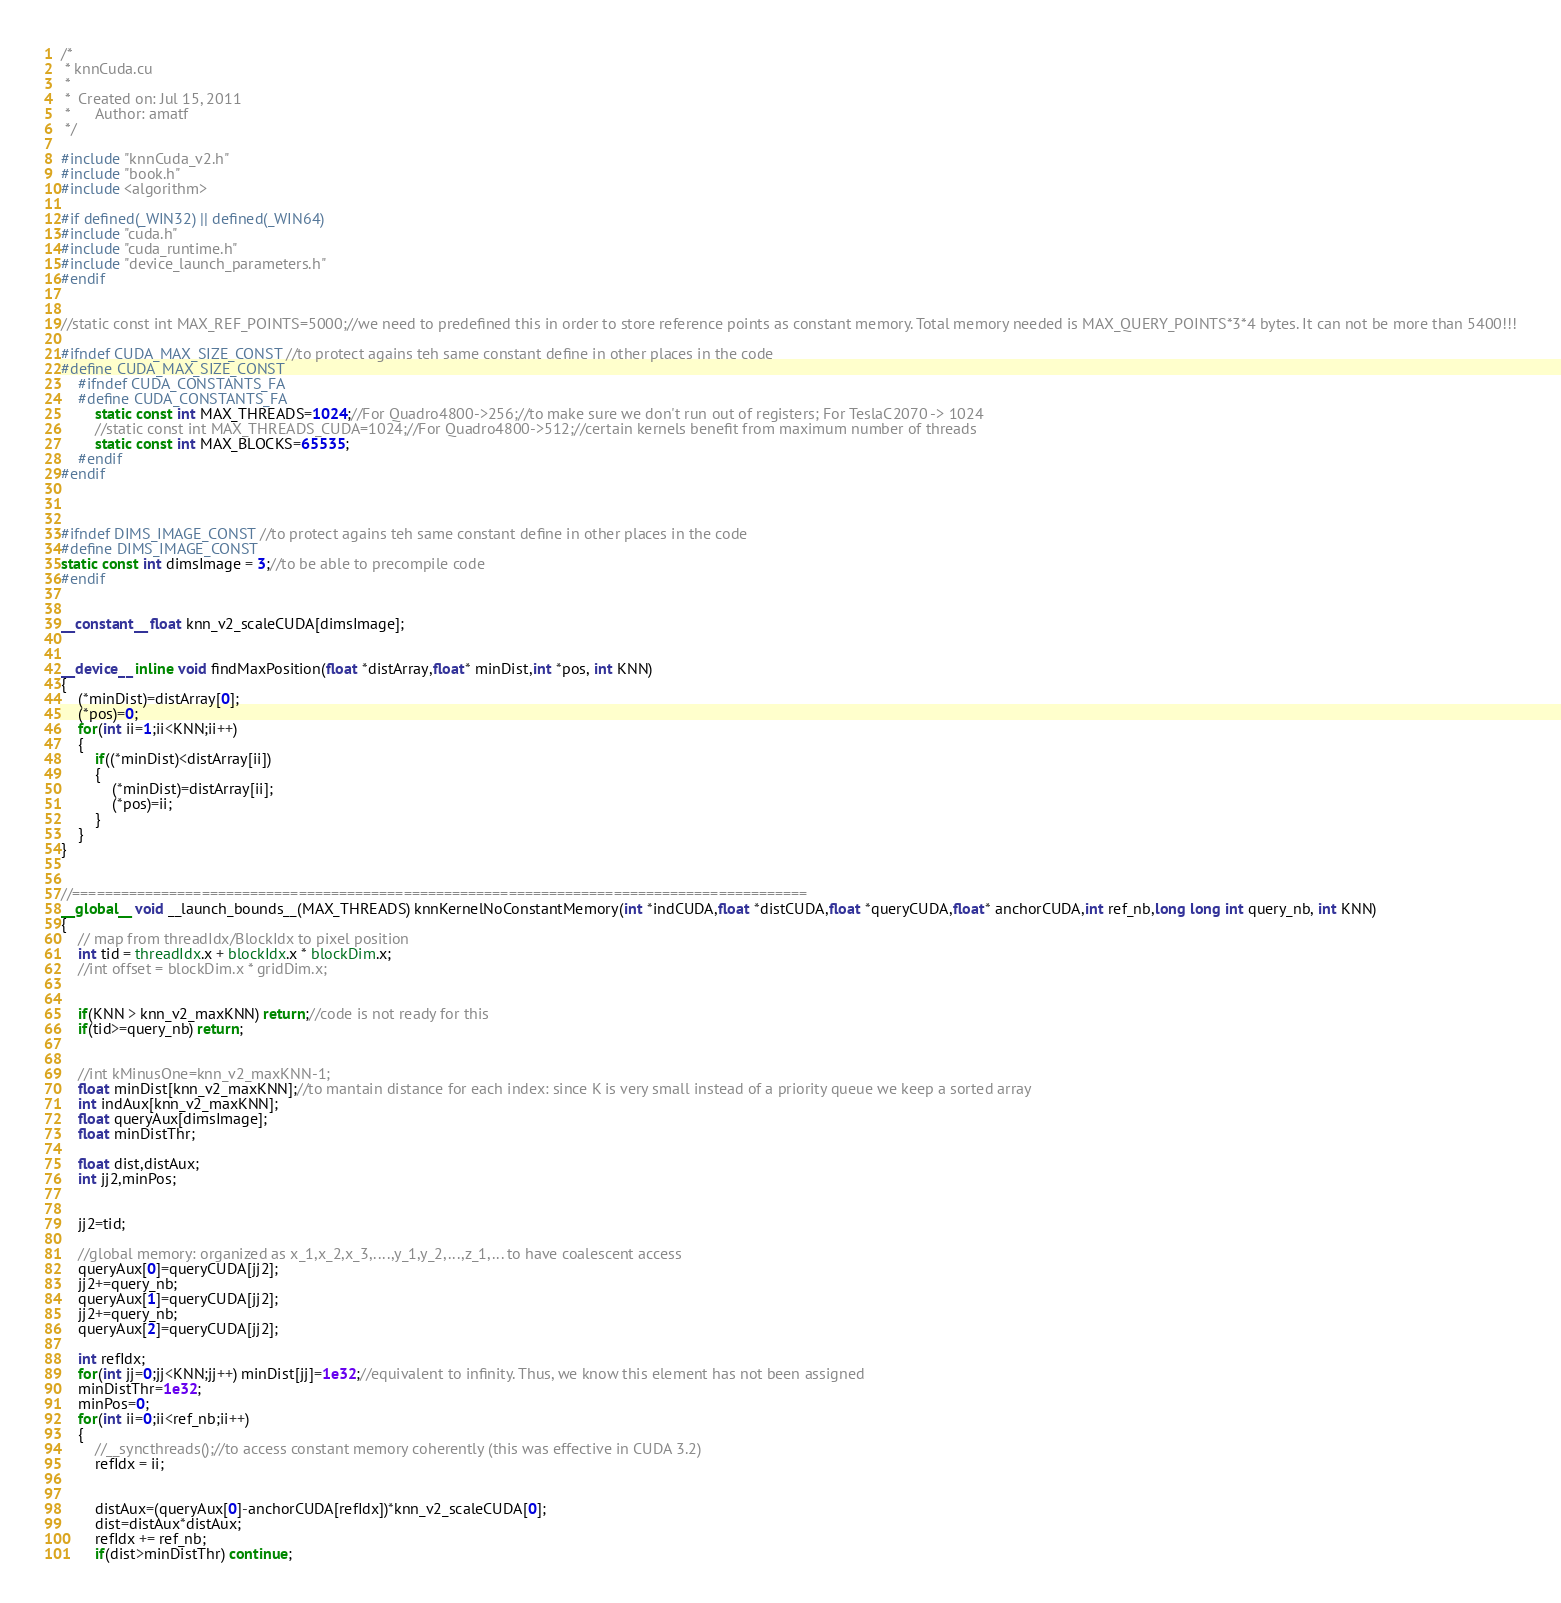<code> <loc_0><loc_0><loc_500><loc_500><_Cuda_>/*
 * knnCuda.cu
 *
 *  Created on: Jul 15, 2011
 *      Author: amatf
 */

#include "knnCuda_v2.h"
#include "book.h"
#include <algorithm>

#if defined(_WIN32) || defined(_WIN64)
#include "cuda.h"
#include "cuda_runtime.h"
#include "device_launch_parameters.h"
#endif


//static const int MAX_REF_POINTS=5000;//we need to predefined this in order to store reference points as constant memory. Total memory needed is MAX_QUERY_POINTS*3*4 bytes. It can not be more than 5400!!!

#ifndef CUDA_MAX_SIZE_CONST //to protect agains teh same constant define in other places in the code
#define CUDA_MAX_SIZE_CONST
    #ifndef CUDA_CONSTANTS_FA
    #define CUDA_CONSTANTS_FA
        static const int MAX_THREADS=1024;//For Quadro4800->256;//to make sure we don't run out of registers; For TeslaC2070 -> 1024
        //static const int MAX_THREADS_CUDA=1024;//For Quadro4800->512;//certain kernels benefit from maximum number of threads
        static const int MAX_BLOCKS=65535;
    #endif
#endif



#ifndef DIMS_IMAGE_CONST //to protect agains teh same constant define in other places in the code
#define DIMS_IMAGE_CONST
static const int dimsImage = 3;//to be able to precompile code
#endif


__constant__ float knn_v2_scaleCUDA[dimsImage];


__device__ inline void findMaxPosition(float *distArray,float* minDist,int *pos, int KNN)
{
	(*minDist)=distArray[0];
	(*pos)=0;
	for(int ii=1;ii<KNN;ii++) 
	{
		if((*minDist)<distArray[ii])
		{
			(*minDist)=distArray[ii];
			(*pos)=ii;
		}
	}
}


//===========================================================================================
__global__ void __launch_bounds__(MAX_THREADS) knnKernelNoConstantMemory(int *indCUDA,float *distCUDA,float *queryCUDA,float* anchorCUDA,int ref_nb,long long int query_nb, int KNN)
{
	// map from threadIdx/BlockIdx to pixel position
	int tid = threadIdx.x + blockIdx.x * blockDim.x;
	//int offset = blockDim.x * gridDim.x;


	if(KNN > knn_v2_maxKNN) return;//code is not ready for this
	if(tid>=query_nb) return;

	
	//int kMinusOne=knn_v2_maxKNN-1;
	float minDist[knn_v2_maxKNN];//to mantain distance for each index: since K is very small instead of a priority queue we keep a sorted array
	int indAux[knn_v2_maxKNN];
	float queryAux[dimsImage];
	float minDistThr;
	
	float dist,distAux;
	int jj2,minPos;


	jj2=tid;

	//global memory: organized as x_1,x_2,x_3,....,y_1,y_2,...,z_1,... to have coalescent access
	queryAux[0]=queryCUDA[jj2];
	jj2+=query_nb;
	queryAux[1]=queryCUDA[jj2];
	jj2+=query_nb;
	queryAux[2]=queryCUDA[jj2];

	int refIdx;
	for(int jj=0;jj<KNN;jj++) minDist[jj]=1e32;//equivalent to infinity. Thus, we know this element has not been assigned
	minDistThr=1e32;
	minPos=0;
	for(int ii=0;ii<ref_nb;ii++)
	{
		//__syncthreads();//to access constant memory coherently (this was effective in CUDA 3.2)
		refIdx = ii;
		

		distAux=(queryAux[0]-anchorCUDA[refIdx])*knn_v2_scaleCUDA[0];
		dist=distAux*distAux;
		refIdx += ref_nb;
		if(dist>minDistThr) continue;</code> 